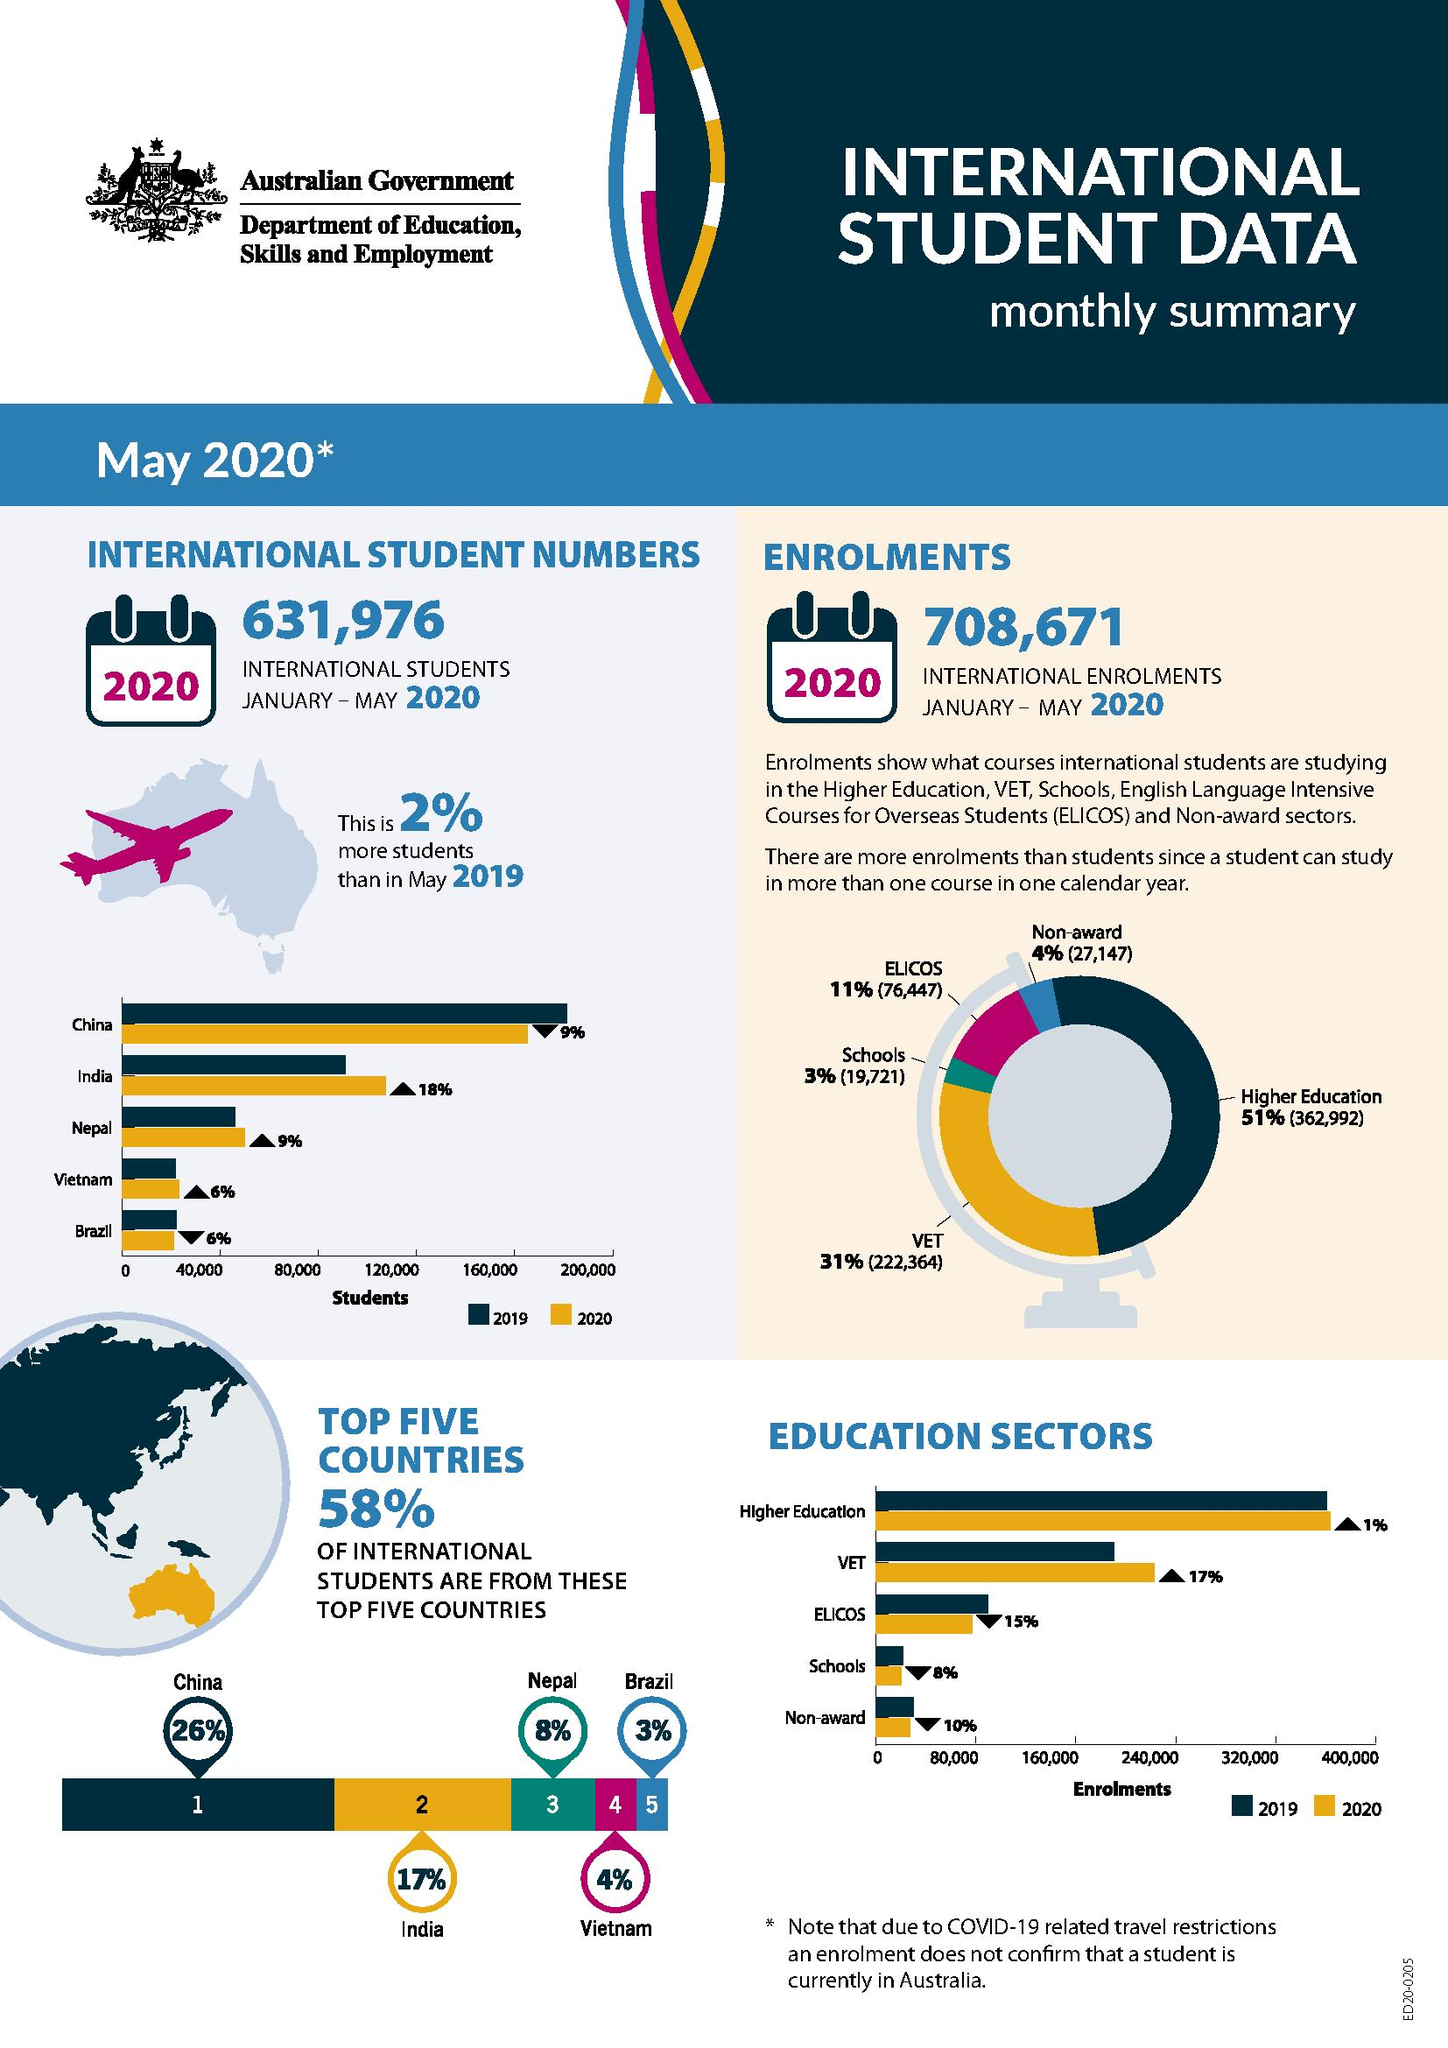Specify some key components in this picture. As of my knowledge cutoff date, there were at least one education sector with enrolments greater than 320,000. Australia has the second-highest number of students from India. The fourth largest number of students in Australia come from foreign countries, with the largest number of students coming from Vietnam. There was a 6% decrease in the number of students from the previous year, and this was particularly noticeable in Brazil. In the year 2020, there were 708,671 international enrolments in Australia. 